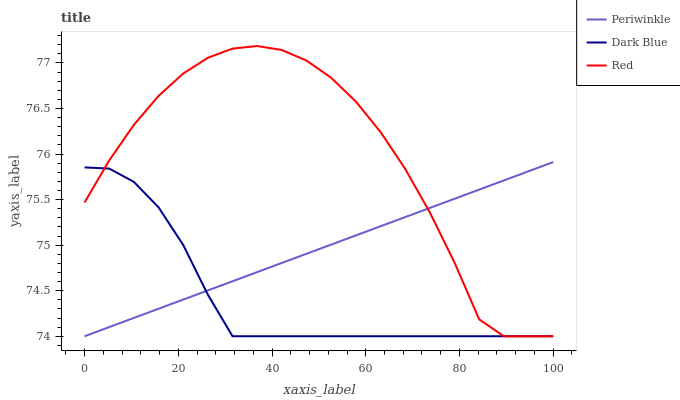Does Dark Blue have the minimum area under the curve?
Answer yes or no. Yes. Does Red have the maximum area under the curve?
Answer yes or no. Yes. Does Periwinkle have the minimum area under the curve?
Answer yes or no. No. Does Periwinkle have the maximum area under the curve?
Answer yes or no. No. Is Periwinkle the smoothest?
Answer yes or no. Yes. Is Red the roughest?
Answer yes or no. Yes. Is Red the smoothest?
Answer yes or no. No. Is Periwinkle the roughest?
Answer yes or no. No. Does Red have the highest value?
Answer yes or no. Yes. Does Periwinkle have the highest value?
Answer yes or no. No. Does Periwinkle intersect Dark Blue?
Answer yes or no. Yes. Is Periwinkle less than Dark Blue?
Answer yes or no. No. Is Periwinkle greater than Dark Blue?
Answer yes or no. No. 